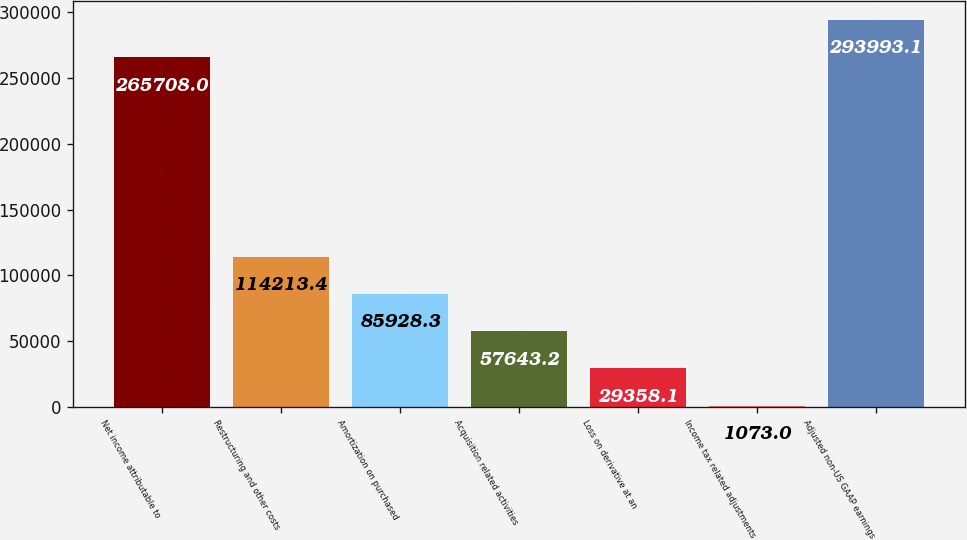Convert chart to OTSL. <chart><loc_0><loc_0><loc_500><loc_500><bar_chart><fcel>Net income attributable to<fcel>Restructuring and other costs<fcel>Amortization on purchased<fcel>Acquisition related activities<fcel>Loss on derivative at an<fcel>Income tax related adjustments<fcel>Adjusted non-US GAAP earnings<nl><fcel>265708<fcel>114213<fcel>85928.3<fcel>57643.2<fcel>29358.1<fcel>1073<fcel>293993<nl></chart> 